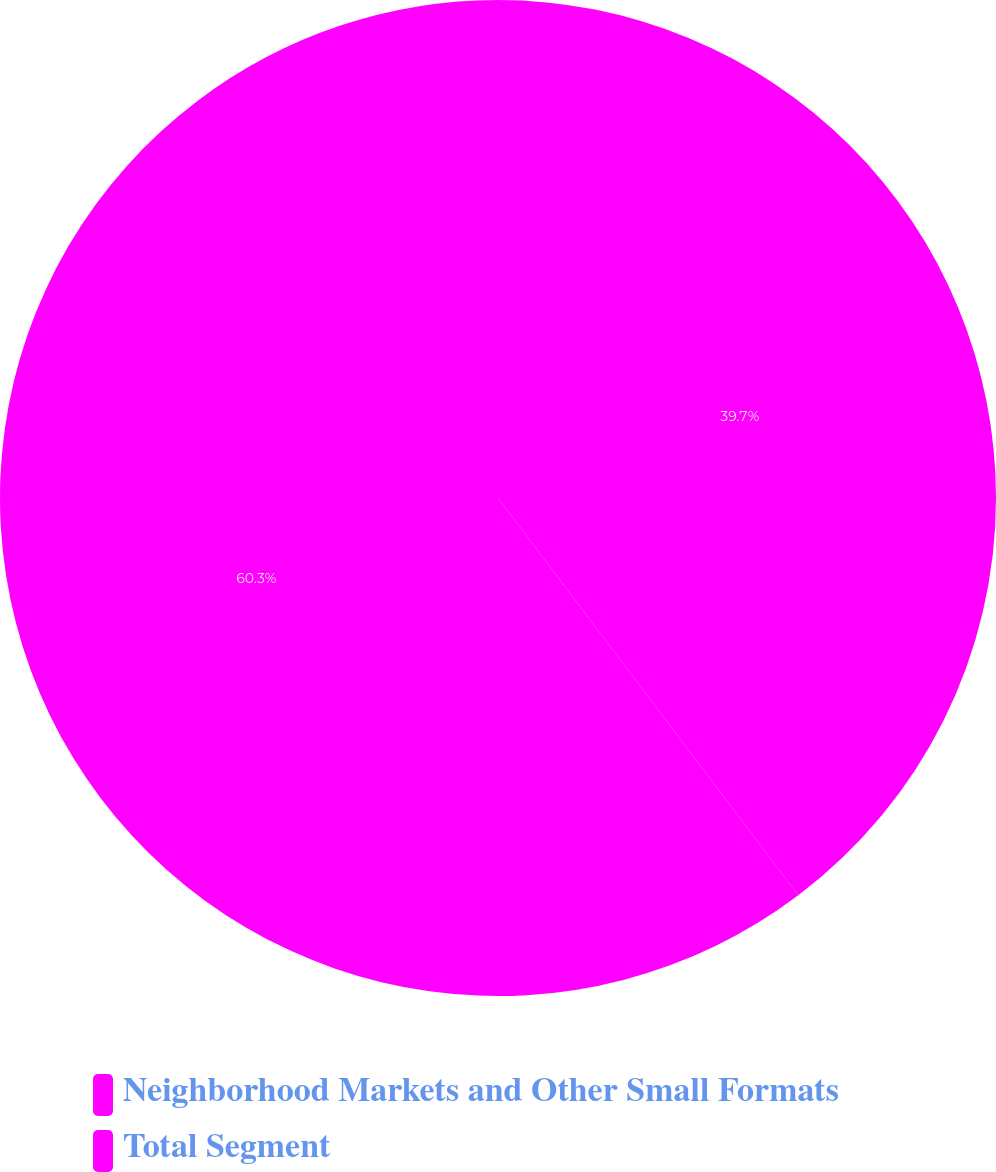Convert chart. <chart><loc_0><loc_0><loc_500><loc_500><pie_chart><fcel>Neighborhood Markets and Other Small Formats<fcel>Total Segment<nl><fcel>39.7%<fcel>60.3%<nl></chart> 